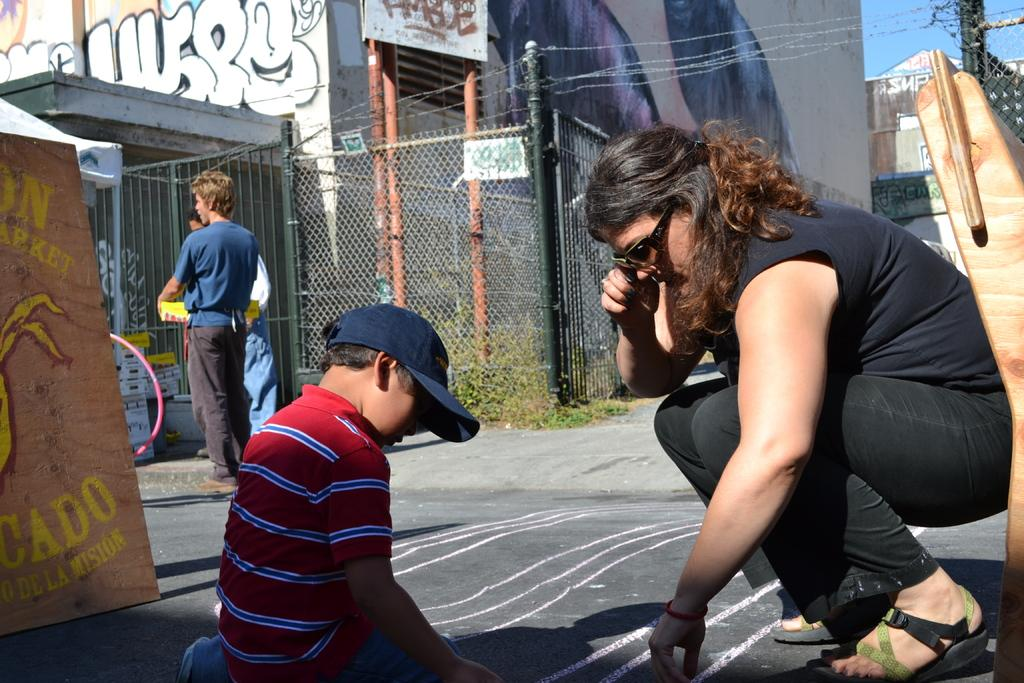What is happening in the image? There are persons on the road in the image. What can be seen in the background of the image? There is a building and the sky visible in the background of the image. What type of lace can be seen on the tramp's clothing in the image? There is no tramp present in the image, and therefore no clothing or lace can be observed. 